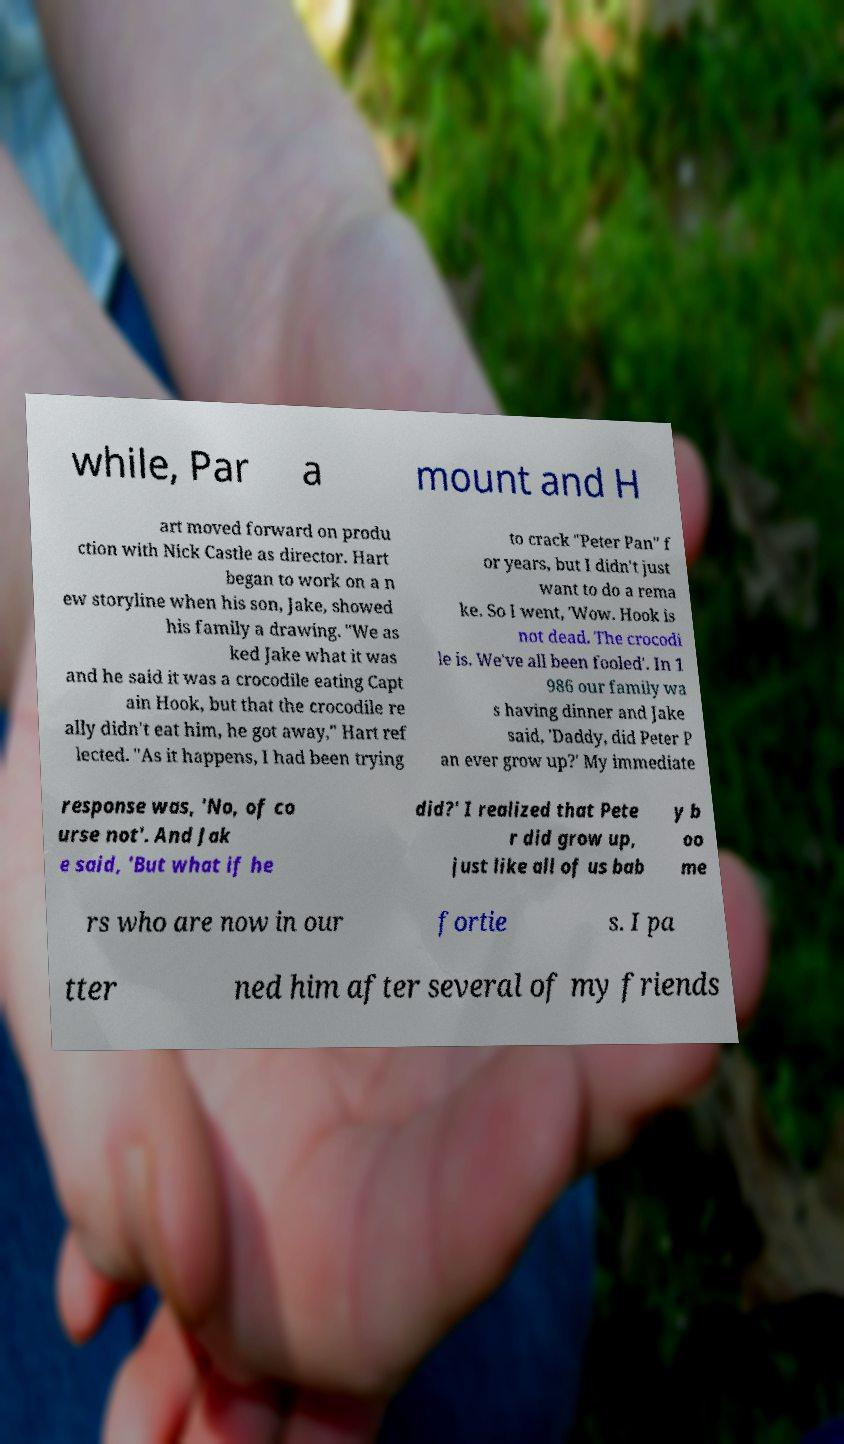Please read and relay the text visible in this image. What does it say? while, Par a mount and H art moved forward on produ ction with Nick Castle as director. Hart began to work on a n ew storyline when his son, Jake, showed his family a drawing. "We as ked Jake what it was and he said it was a crocodile eating Capt ain Hook, but that the crocodile re ally didn't eat him, he got away," Hart ref lected. "As it happens, I had been trying to crack "Peter Pan" f or years, but I didn't just want to do a rema ke. So I went, 'Wow. Hook is not dead. The crocodi le is. We've all been fooled'. In 1 986 our family wa s having dinner and Jake said, 'Daddy, did Peter P an ever grow up?' My immediate response was, 'No, of co urse not'. And Jak e said, 'But what if he did?' I realized that Pete r did grow up, just like all of us bab y b oo me rs who are now in our fortie s. I pa tter ned him after several of my friends 